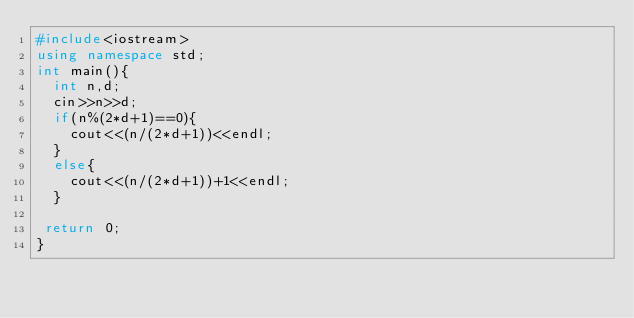Convert code to text. <code><loc_0><loc_0><loc_500><loc_500><_C++_>#include<iostream>
using namespace std;
int main(){
  int n,d;
  cin>>n>>d;
  if(n%(2*d+1)==0){
  	cout<<(n/(2*d+1))<<endl;
  }
  else{
    cout<<(n/(2*d+1))+1<<endl;
  }
  
 return 0; 
}</code> 